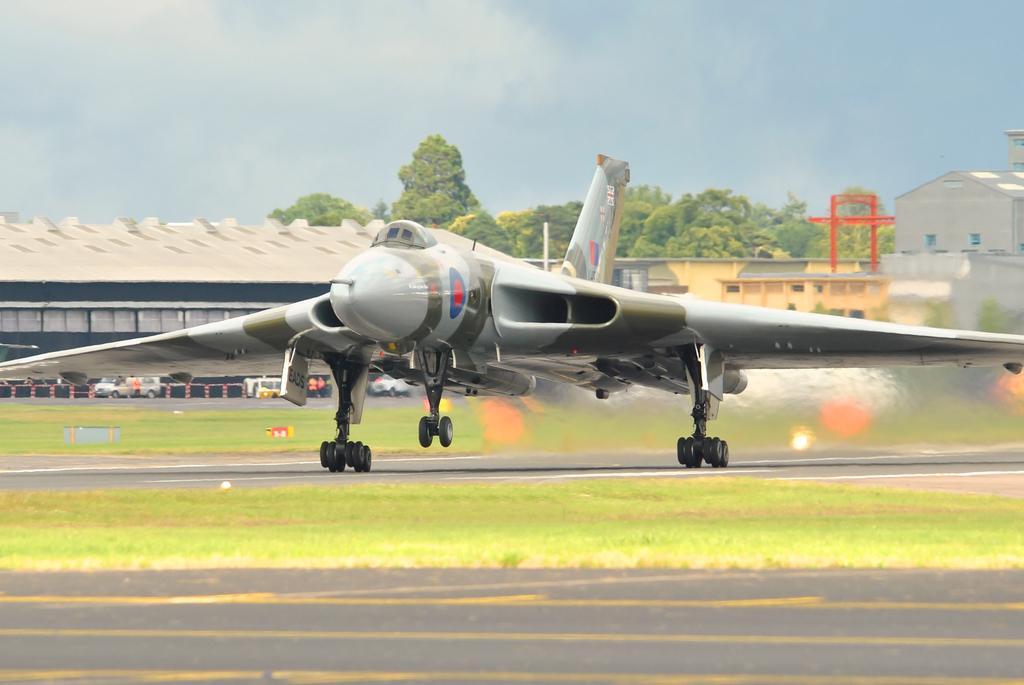Could you give a brief overview of what you see in this image? This picture shows a jet plane on the runway and we see buildings and trees and few cars and we see grass on the ground and a blue cloudy Sky. 